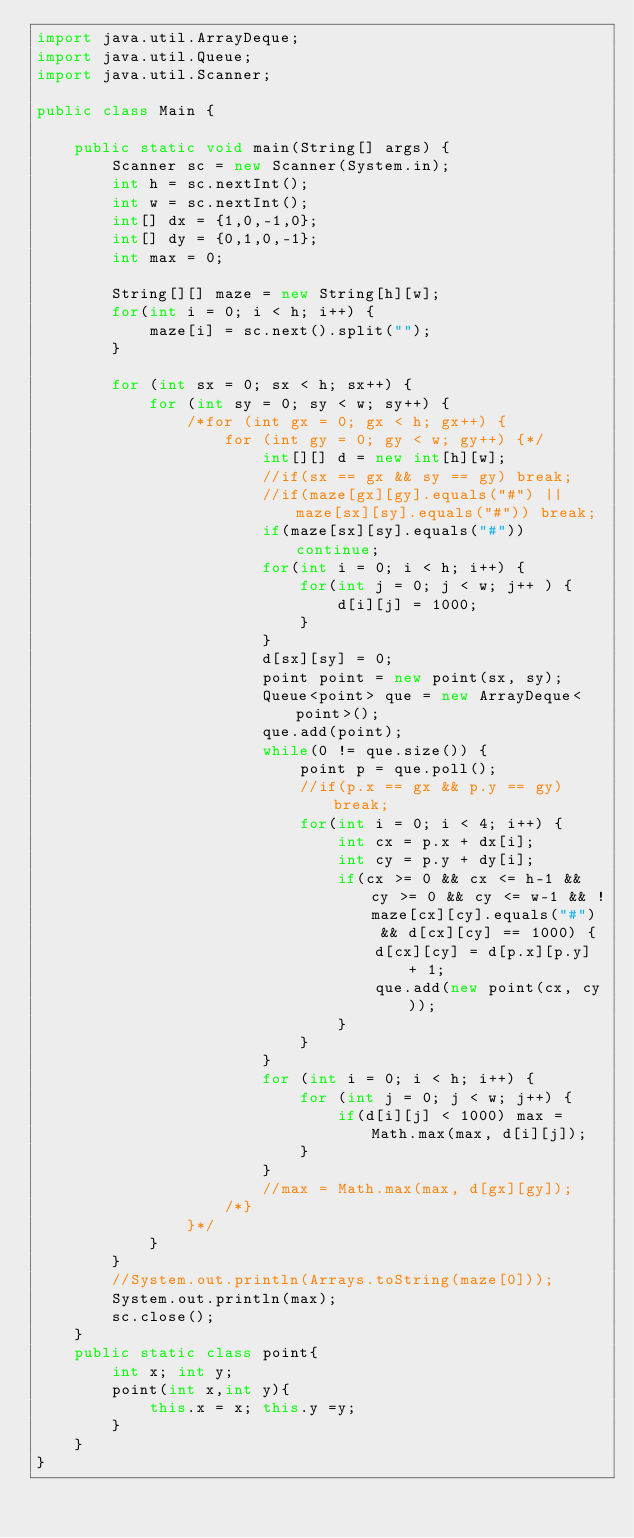<code> <loc_0><loc_0><loc_500><loc_500><_Java_>import java.util.ArrayDeque;
import java.util.Queue;
import java.util.Scanner;

public class Main {

	public static void main(String[] args) {
		Scanner sc = new Scanner(System.in);
		int h = sc.nextInt();
		int w = sc.nextInt();
		int[] dx = {1,0,-1,0};
		int[] dy = {0,1,0,-1};
		int max = 0;

		String[][] maze = new String[h][w];
		for(int i = 0; i < h; i++) {
			maze[i] = sc.next().split("");
		}

		for (int sx = 0; sx < h; sx++) {
			for (int sy = 0; sy < w; sy++) {
				/*for (int gx = 0; gx < h; gx++) {
					for (int gy = 0; gy < w; gy++) {*/
						int[][] d = new int[h][w];
						//if(sx == gx && sy == gy) break;
						//if(maze[gx][gy].equals("#") || maze[sx][sy].equals("#")) break;
						if(maze[sx][sy].equals("#")) continue;
						for(int i = 0; i < h; i++) {
							for(int j = 0; j < w; j++ ) {
								d[i][j] = 1000;
							}
						}
						d[sx][sy] = 0;
						point point = new point(sx, sy);
						Queue<point> que = new ArrayDeque<point>();
						que.add(point);
						while(0 != que.size()) {
							point p = que.poll();
							//if(p.x == gx && p.y == gy) break;
							for(int i = 0; i < 4; i++) {
								int cx = p.x + dx[i];
								int cy = p.y + dy[i];
								if(cx >= 0 && cx <= h-1 && cy >= 0 && cy <= w-1 && !maze[cx][cy].equals("#")  && d[cx][cy] == 1000) {
									d[cx][cy] = d[p.x][p.y] + 1;
									que.add(new point(cx, cy));
								}
							}
						}
						for (int i = 0; i < h; i++) {
							for (int j = 0; j < w; j++) {
								if(d[i][j] < 1000) max = Math.max(max, d[i][j]);
							}
						}
						//max = Math.max(max, d[gx][gy]);
					/*}
				}*/
			}
		}
		//System.out.println(Arrays.toString(maze[0]));
		System.out.println(max);
		sc.close();
	}
	public static class point{
		int x; int y;
		point(int x,int y){
			this.x = x; this.y =y;
		}
	}
}</code> 